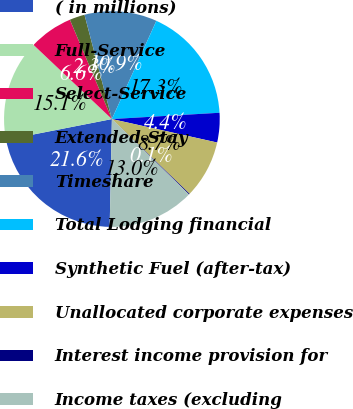Convert chart to OTSL. <chart><loc_0><loc_0><loc_500><loc_500><pie_chart><fcel>( in millions)<fcel>Full-Service<fcel>Select-Service<fcel>Extended-Stay<fcel>Timeshare<fcel>Total Lodging financial<fcel>Synthetic Fuel (after-tax)<fcel>Unallocated corporate expenses<fcel>Interest income provision for<fcel>Income taxes (excluding<nl><fcel>21.59%<fcel>15.15%<fcel>6.57%<fcel>2.28%<fcel>10.86%<fcel>17.3%<fcel>4.42%<fcel>8.71%<fcel>0.13%<fcel>13.0%<nl></chart> 